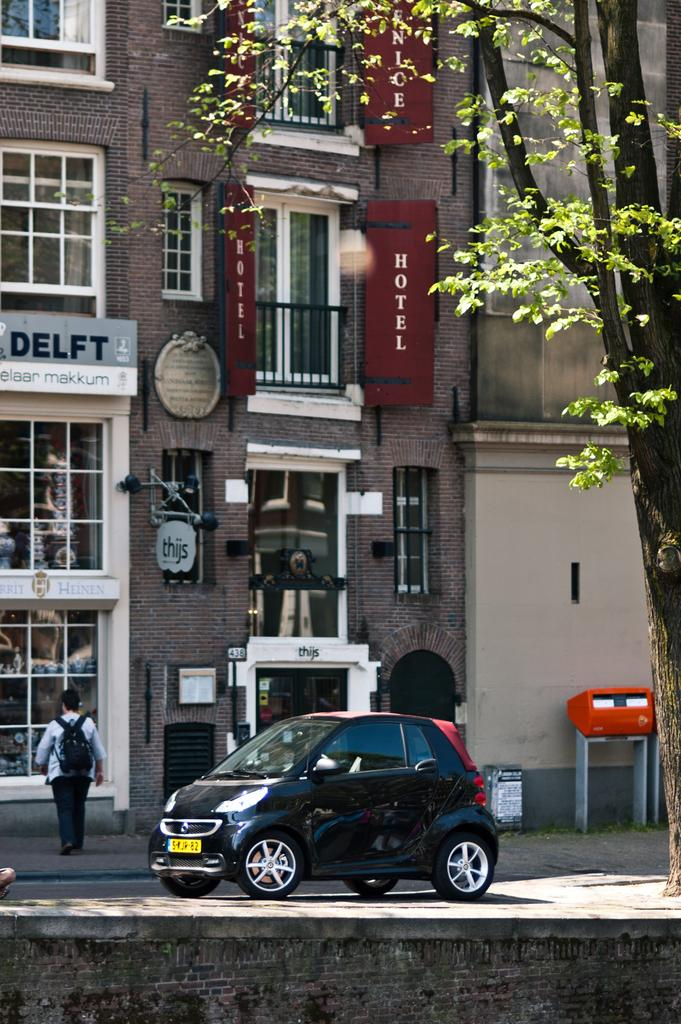Who or what is the main subject in the image? There is a person in the image. Where is the person located in relation to the building? The person is in front of a building. What type of vehicle can be seen at the bottom of the image? There is a car at the bottom of the image. What type of vegetation is on the right side of the image? There is a tree on the right side of the image. Where is the faucet located in the image? There is no faucet present in the image. What type of quartz can be seen in the image? There is no quartz present in the image. 